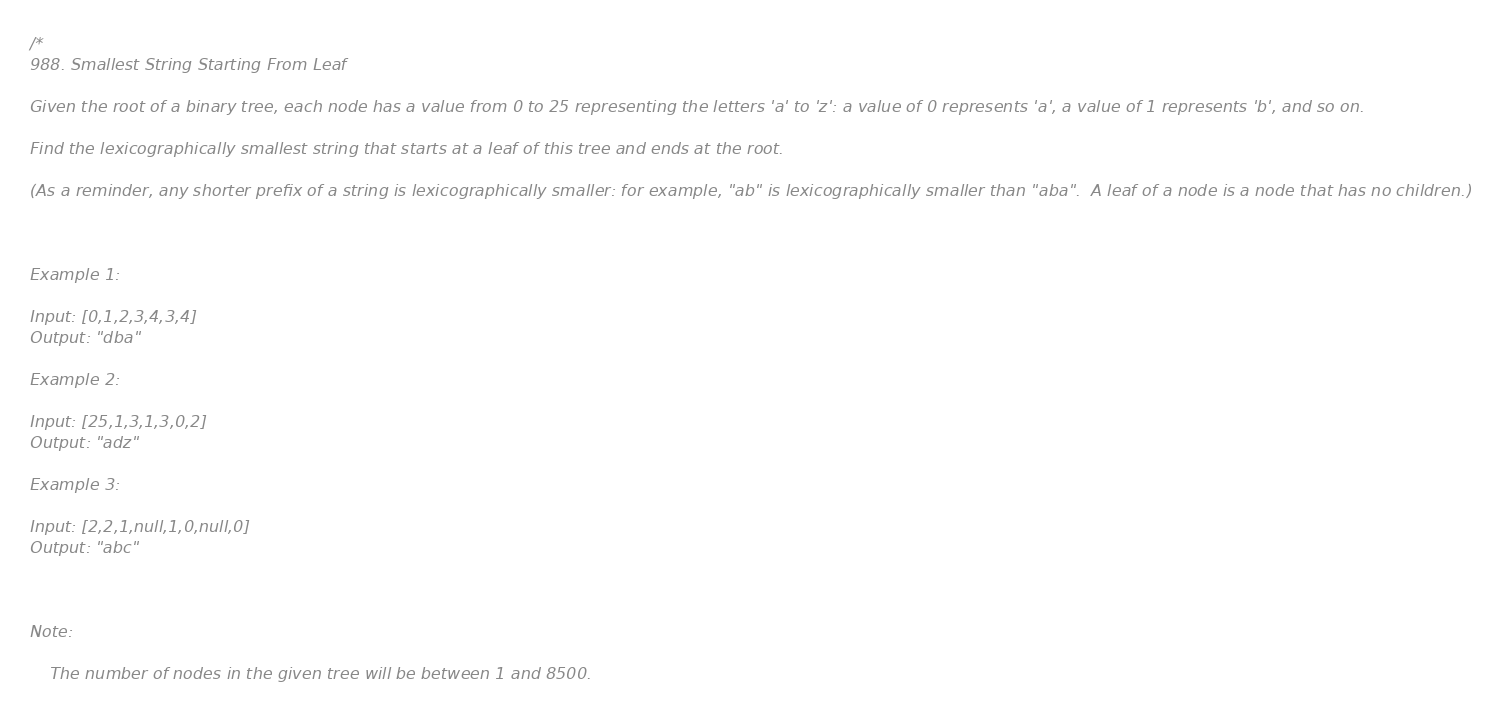<code> <loc_0><loc_0><loc_500><loc_500><_Swift_>/*
988. Smallest String Starting From Leaf

Given the root of a binary tree, each node has a value from 0 to 25 representing the letters 'a' to 'z': a value of 0 represents 'a', a value of 1 represents 'b', and so on.

Find the lexicographically smallest string that starts at a leaf of this tree and ends at the root.

(As a reminder, any shorter prefix of a string is lexicographically smaller: for example, "ab" is lexicographically smaller than "aba".  A leaf of a node is a node that has no children.)

 

Example 1:

Input: [0,1,2,3,4,3,4]
Output: "dba"

Example 2:

Input: [25,1,3,1,3,0,2]
Output: "adz"

Example 3:

Input: [2,2,1,null,1,0,null,0]
Output: "abc"

 

Note:

    The number of nodes in the given tree will be between 1 and 8500.</code> 